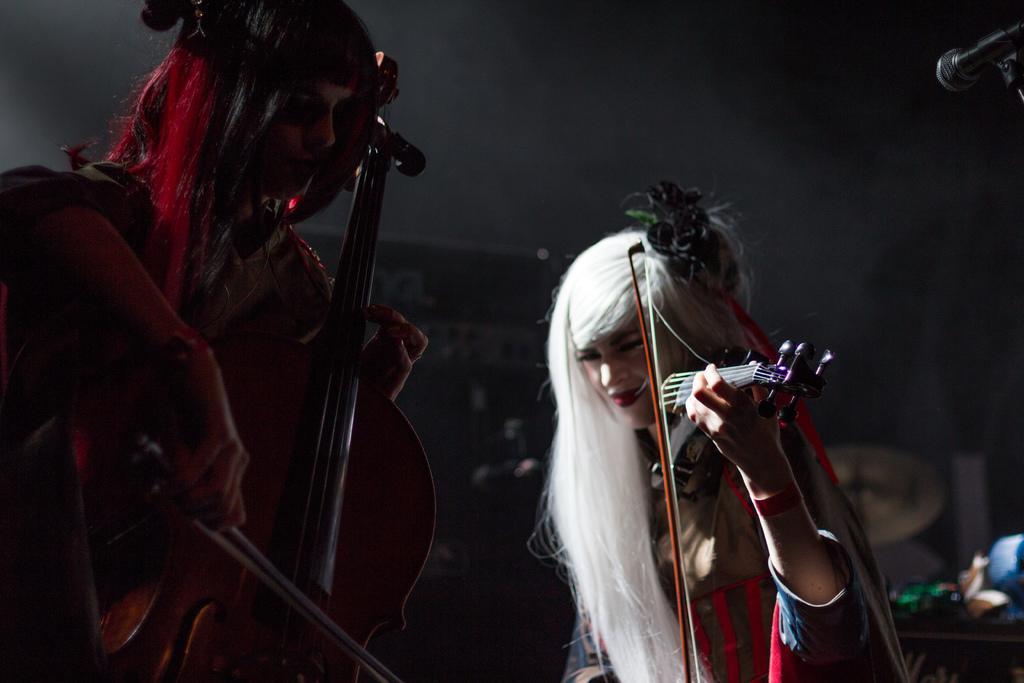In one or two sentences, can you explain what this image depicts? In this picture there are two persons playing violin. At the back there are drums and there are objects. At the top right there is a microphone. 